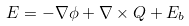<formula> <loc_0><loc_0><loc_500><loc_500>E = - \nabla \phi + \nabla \times Q + E _ { b }</formula> 